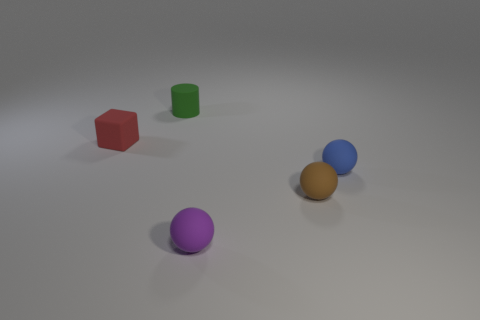There is a tiny thing behind the tiny thing that is to the left of the tiny green rubber cylinder behind the brown thing; what is its material?
Keep it short and to the point. Rubber. Is the number of tiny green matte cylinders that are on the right side of the brown matte thing less than the number of small matte things that are to the left of the cylinder?
Offer a very short reply. Yes. How many tiny purple spheres have the same material as the tiny cylinder?
Provide a short and direct response. 1. Is there a brown thing that is in front of the matte thing that is behind the tiny object that is left of the green rubber cylinder?
Provide a short and direct response. Yes. How many blocks are either purple matte objects or tiny green things?
Ensure brevity in your answer.  0. Do the blue matte thing and the matte object in front of the small brown matte thing have the same shape?
Your answer should be very brief. Yes. Is the number of brown matte things to the left of the brown ball less than the number of cyan blocks?
Your answer should be compact. No. There is a tiny red cube; are there any tiny blue rubber balls to the right of it?
Your response must be concise. Yes. Are there any tiny blue things of the same shape as the purple rubber thing?
Your response must be concise. Yes. There is a green matte object that is the same size as the red object; what is its shape?
Keep it short and to the point. Cylinder. 